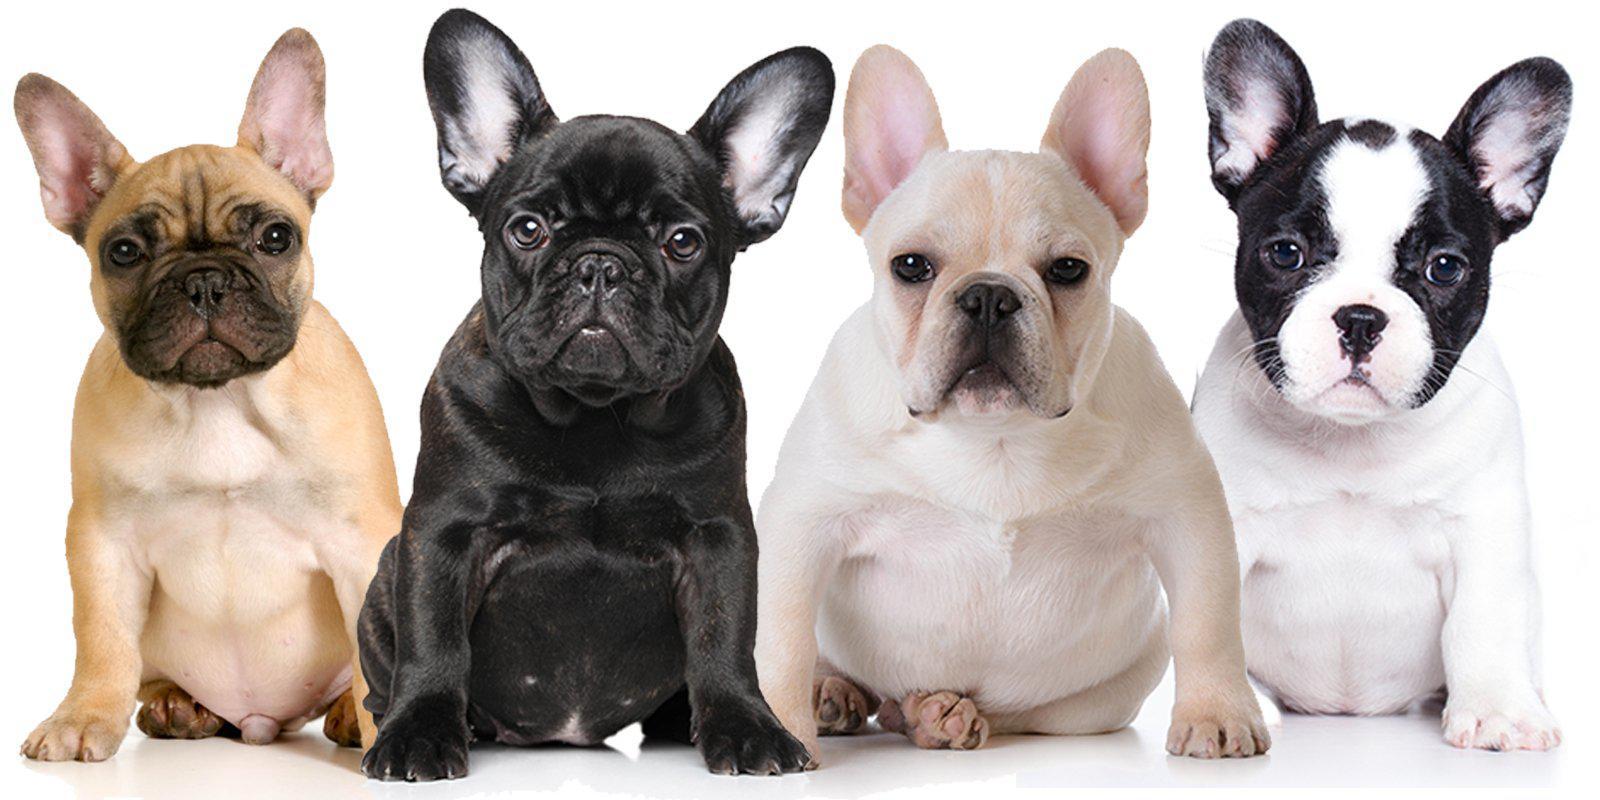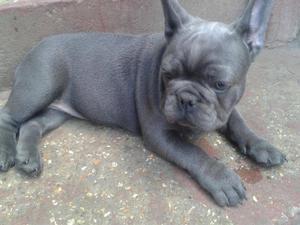The first image is the image on the left, the second image is the image on the right. Considering the images on both sides, is "The right image contains exactly three dogs." valid? Answer yes or no. No. The first image is the image on the left, the second image is the image on the right. Considering the images on both sides, is "Each image contains the same number of dogs, and all dogs are posed side-by-side." valid? Answer yes or no. No. 